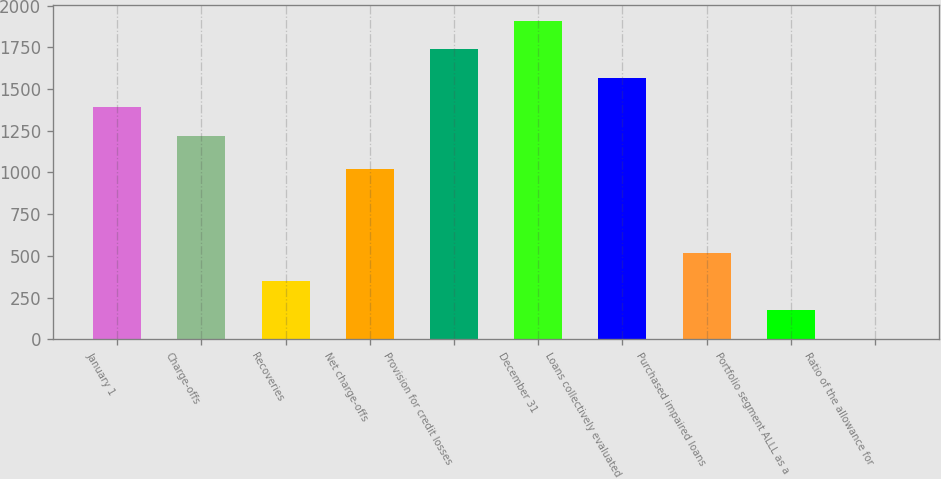<chart> <loc_0><loc_0><loc_500><loc_500><bar_chart><fcel>January 1<fcel>Charge-offs<fcel>Recoveries<fcel>Net charge-offs<fcel>Provision for credit losses<fcel>December 31<fcel>Loans collectively evaluated<fcel>Purchased impaired loans<fcel>Portfolio segment ALLL as a<fcel>Ratio of the allowance for<nl><fcel>1392.47<fcel>1220<fcel>347.29<fcel>1022<fcel>1737.39<fcel>1909.86<fcel>1564.93<fcel>519.76<fcel>174.82<fcel>2.35<nl></chart> 